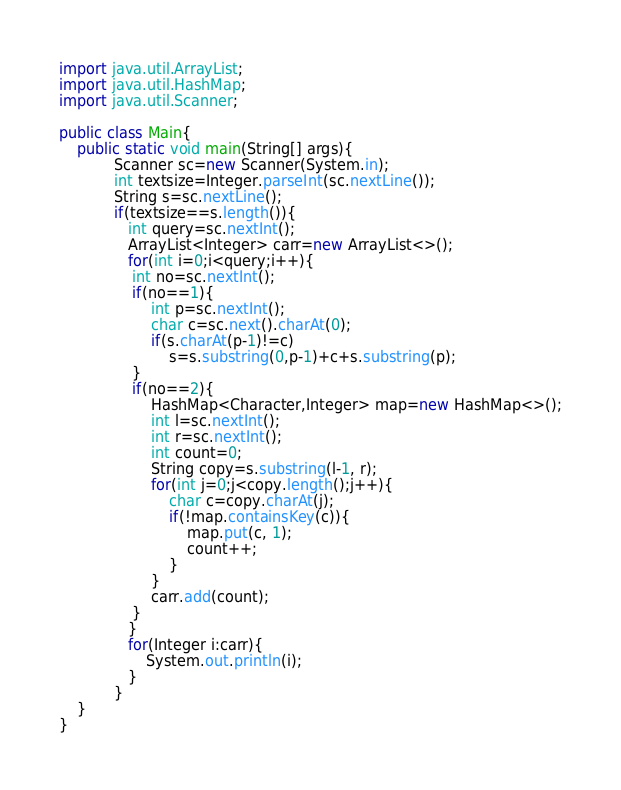<code> <loc_0><loc_0><loc_500><loc_500><_Java_>import java.util.ArrayList;
import java.util.HashMap;
import java.util.Scanner;

public class Main{
	public static void main(String[] args){
            Scanner sc=new Scanner(System.in);
            int textsize=Integer.parseInt(sc.nextLine());
            String s=sc.nextLine();
            if(textsize==s.length()){
               int query=sc.nextInt();
               ArrayList<Integer> carr=new ArrayList<>();
               for(int i=0;i<query;i++){
                int no=sc.nextInt();
                if(no==1){
                    int p=sc.nextInt();
                    char c=sc.next().charAt(0);
                    if(s.charAt(p-1)!=c)
                        s=s.substring(0,p-1)+c+s.substring(p);
                }
                if(no==2){
                    HashMap<Character,Integer> map=new HashMap<>();
                    int l=sc.nextInt();
                    int r=sc.nextInt();
                    int count=0;
                    String copy=s.substring(l-1, r);
                    for(int j=0;j<copy.length();j++){
                        char c=copy.charAt(j);
                        if(!map.containsKey(c)){
                            map.put(c, 1);
                            count++;
                        }
                    }
                    carr.add(count);
                }
               }
               for(Integer i:carr){
                   System.out.println(i);
               }
            }
	}
}</code> 